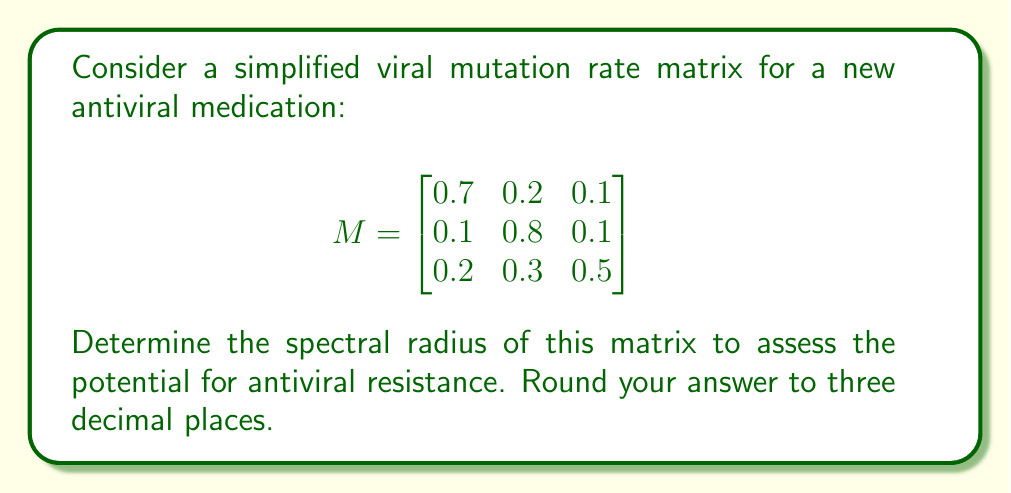What is the answer to this math problem? To determine the spectral radius of the matrix M, we need to follow these steps:

1) First, calculate the characteristic polynomial of M:
   $det(M - \lambda I) = 0$

   $$\begin{vmatrix}
   0.7-\lambda & 0.2 & 0.1 \\
   0.1 & 0.8-\lambda & 0.1 \\
   0.2 & 0.3 & 0.5-\lambda
   \end{vmatrix} = 0$$

2) Expand the determinant:
   $(0.7-\lambda)(0.8-\lambda)(0.5-\lambda) - 0.1 \cdot 0.1 \cdot 0.3 - 0.2 \cdot 0.1 \cdot 0.1 - (0.1 \cdot 0.1 \cdot 0.2 + 0.2 \cdot 0.3 \cdot (0.8-\lambda) + 0.1 \cdot (0.7-\lambda) \cdot 0.3) = 0$

3) Simplify:
   $-\lambda^3 + 2\lambda^2 - 1.09\lambda + 0.194 = 0$

4) Solve this cubic equation. The roots are the eigenvalues of M. Using a numerical method or a computer algebra system, we find the roots:

   $\lambda_1 \approx 0.9039$
   $\lambda_2 \approx 0.5480 + 0.1448i$
   $\lambda_3 \approx 0.5480 - 0.1448i$

5) The spectral radius is the maximum absolute value of the eigenvalues:

   $\rho(M) = \max\{|\lambda_1|, |\lambda_2|, |\lambda_3|\}$

   $|\lambda_1| = 0.9039$
   $|\lambda_2| = |\lambda_3| = \sqrt{0.5480^2 + 0.1448^2} \approx 0.5667$

6) Therefore, the spectral radius is 0.9039, which rounds to 0.904 to three decimal places.
Answer: 0.904 